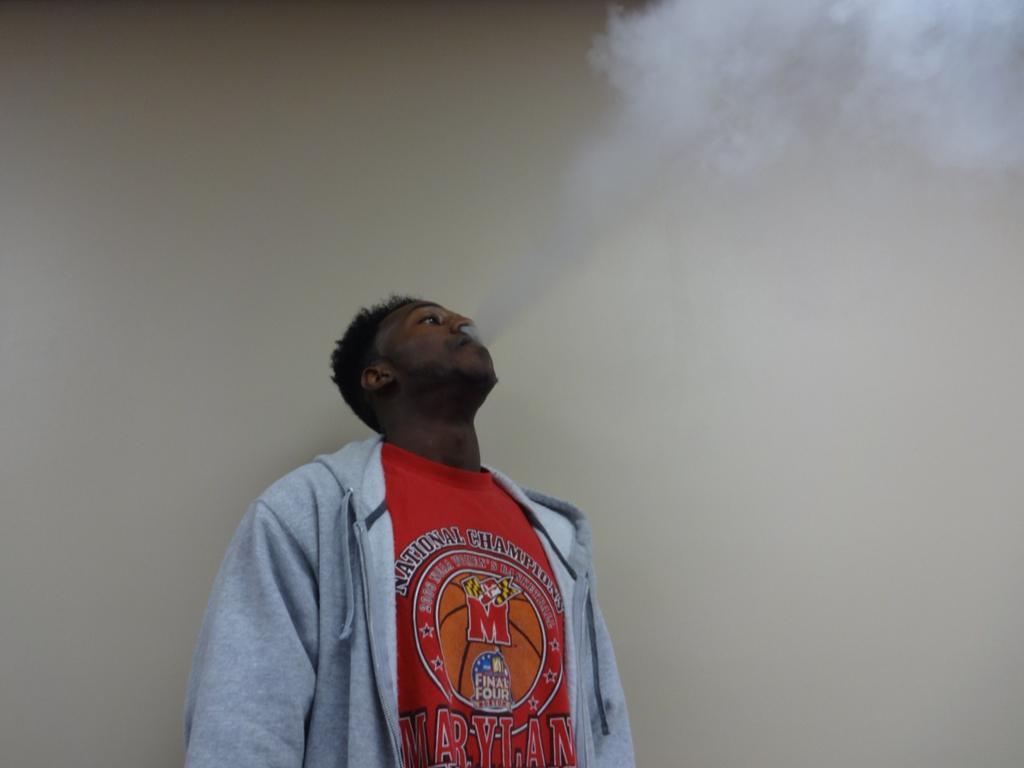<image>
Relay a brief, clear account of the picture shown. A man is exhaling a plume of smoke wearing a national champions tee shirt. 